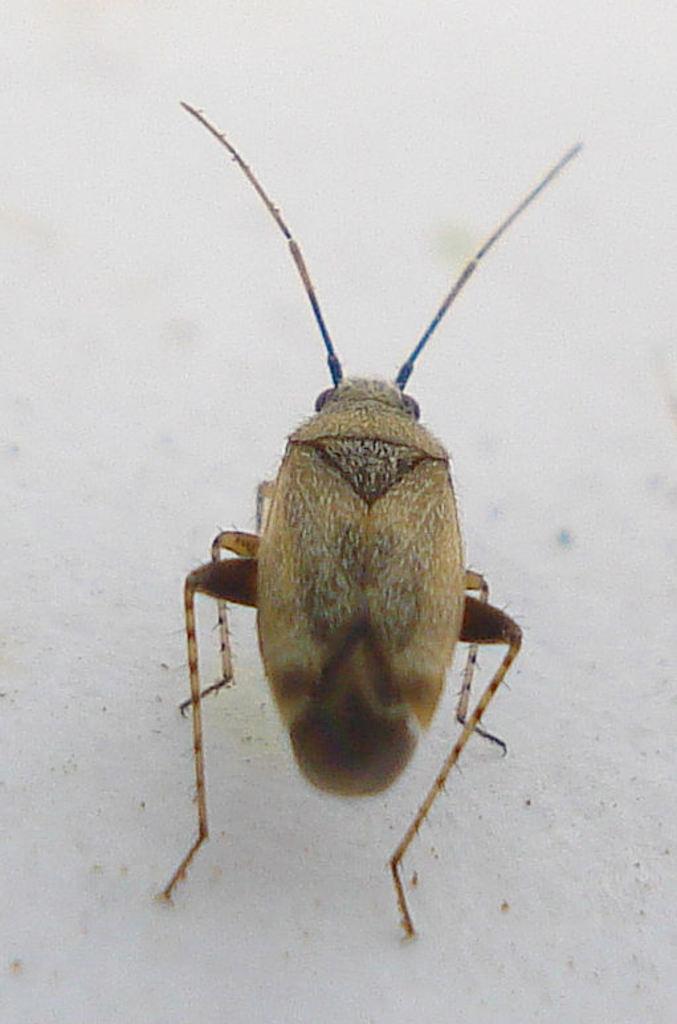In one or two sentences, can you explain what this image depicts? In this image there is an insect, at the background of the image there is a wall truncated. 